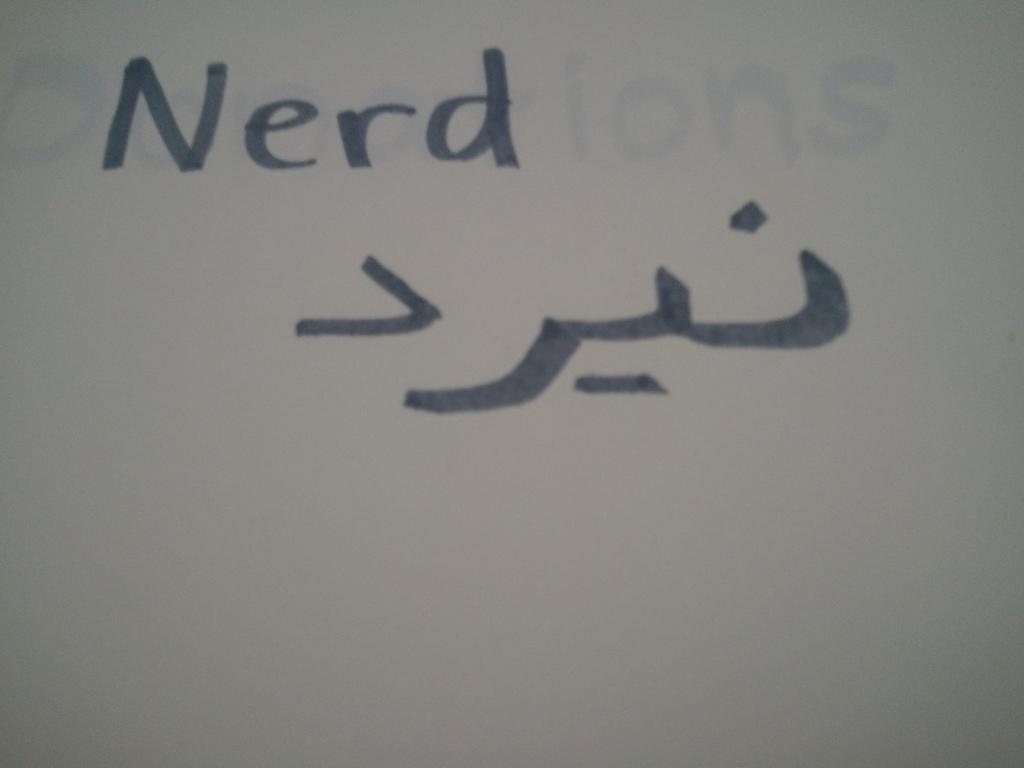<image>
Give a short and clear explanation of the subsequent image. A white board with the word Nerd written in black with some symbols underneath the word. 